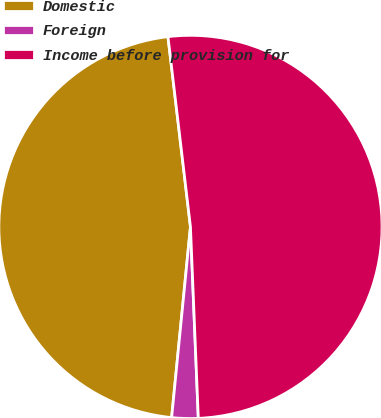Convert chart to OTSL. <chart><loc_0><loc_0><loc_500><loc_500><pie_chart><fcel>Domestic<fcel>Foreign<fcel>Income before provision for<nl><fcel>46.56%<fcel>2.22%<fcel>51.22%<nl></chart> 